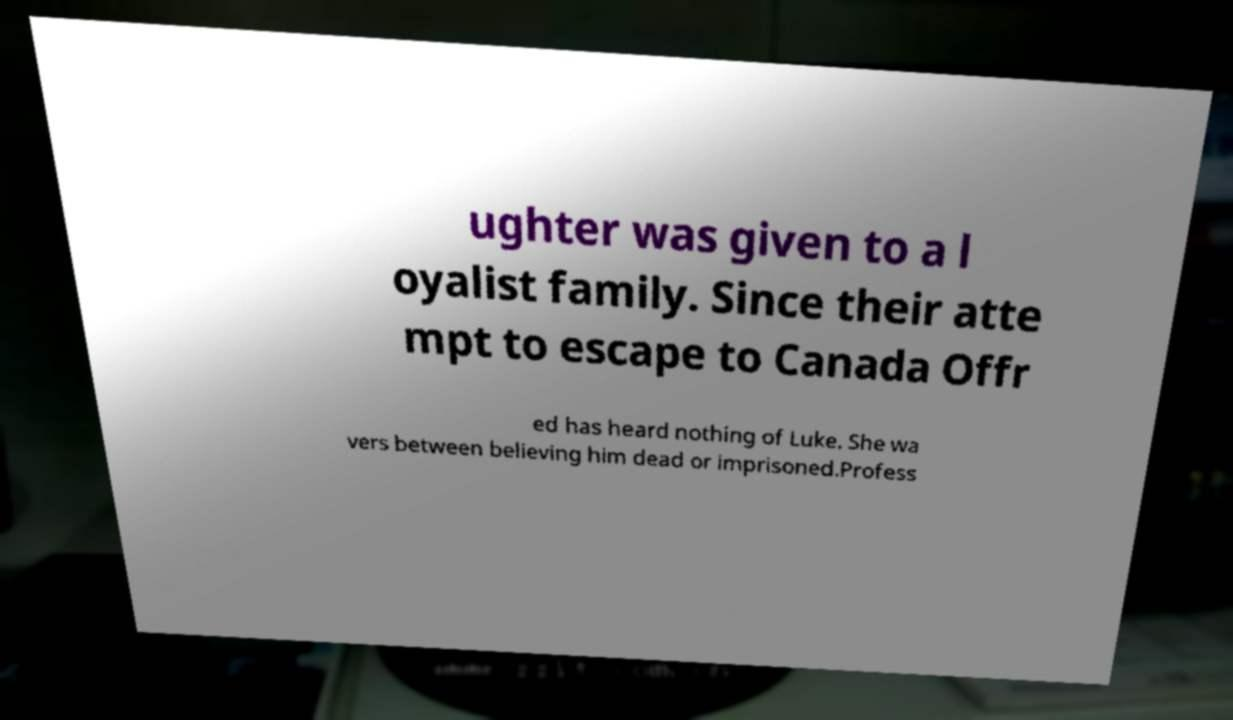Can you read and provide the text displayed in the image?This photo seems to have some interesting text. Can you extract and type it out for me? ughter was given to a l oyalist family. Since their atte mpt to escape to Canada Offr ed has heard nothing of Luke. She wa vers between believing him dead or imprisoned.Profess 